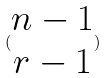<formula> <loc_0><loc_0><loc_500><loc_500>( \begin{matrix} n - 1 \\ r - 1 \end{matrix} )</formula> 